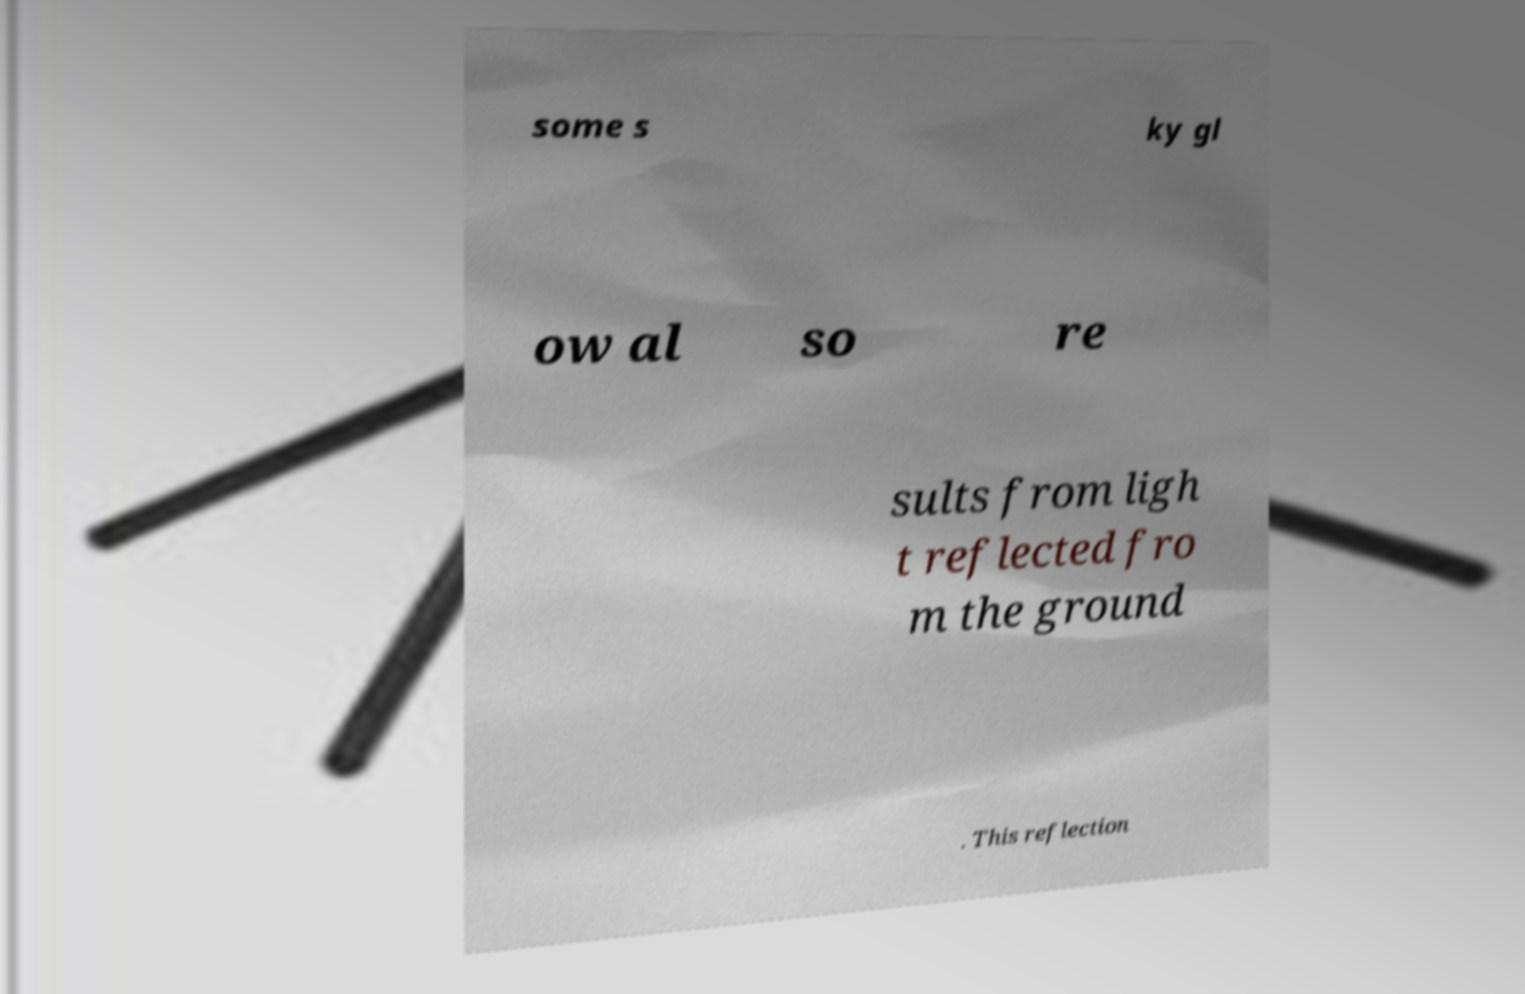Please read and relay the text visible in this image. What does it say? some s ky gl ow al so re sults from ligh t reflected fro m the ground . This reflection 